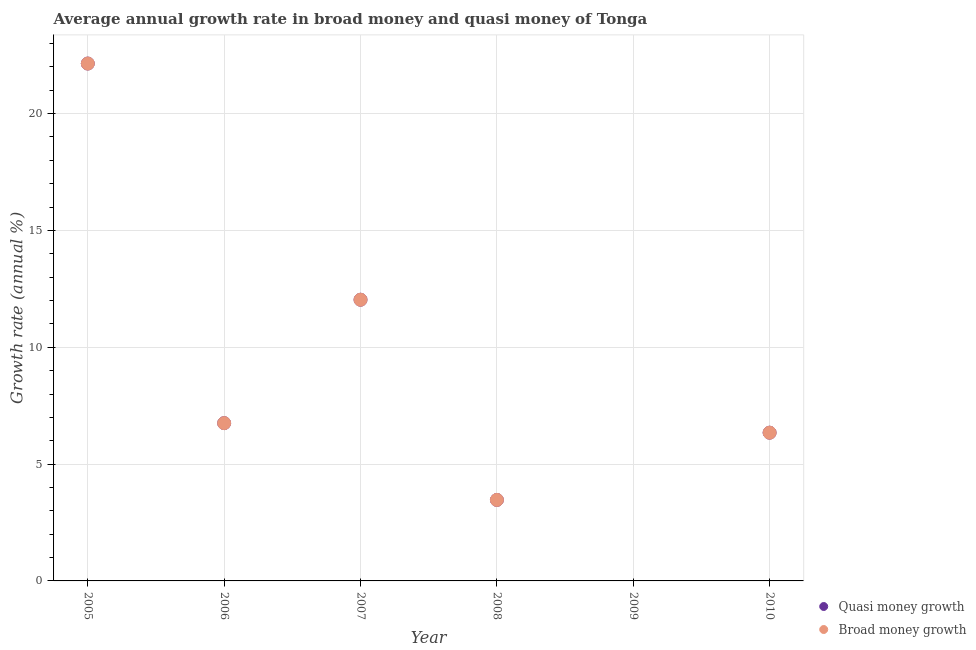Across all years, what is the maximum annual growth rate in broad money?
Keep it short and to the point. 22.14. In which year was the annual growth rate in broad money maximum?
Offer a terse response. 2005. What is the total annual growth rate in broad money in the graph?
Your answer should be compact. 50.74. What is the difference between the annual growth rate in quasi money in 2006 and that in 2010?
Provide a succinct answer. 0.41. What is the difference between the annual growth rate in quasi money in 2010 and the annual growth rate in broad money in 2009?
Provide a short and direct response. 6.34. What is the average annual growth rate in quasi money per year?
Your response must be concise. 8.46. In the year 2007, what is the difference between the annual growth rate in quasi money and annual growth rate in broad money?
Offer a very short reply. 0. In how many years, is the annual growth rate in quasi money greater than 10 %?
Keep it short and to the point. 2. What is the ratio of the annual growth rate in quasi money in 2005 to that in 2007?
Your answer should be very brief. 1.84. Is the difference between the annual growth rate in broad money in 2005 and 2007 greater than the difference between the annual growth rate in quasi money in 2005 and 2007?
Your answer should be very brief. No. What is the difference between the highest and the second highest annual growth rate in broad money?
Keep it short and to the point. 10.11. What is the difference between the highest and the lowest annual growth rate in quasi money?
Your response must be concise. 22.14. In how many years, is the annual growth rate in quasi money greater than the average annual growth rate in quasi money taken over all years?
Provide a succinct answer. 2. Does the annual growth rate in quasi money monotonically increase over the years?
Offer a terse response. No. Does the graph contain any zero values?
Your response must be concise. Yes. Does the graph contain grids?
Your response must be concise. Yes. Where does the legend appear in the graph?
Offer a terse response. Bottom right. How many legend labels are there?
Your answer should be very brief. 2. How are the legend labels stacked?
Offer a terse response. Vertical. What is the title of the graph?
Ensure brevity in your answer.  Average annual growth rate in broad money and quasi money of Tonga. What is the label or title of the Y-axis?
Your answer should be compact. Growth rate (annual %). What is the Growth rate (annual %) of Quasi money growth in 2005?
Provide a short and direct response. 22.14. What is the Growth rate (annual %) in Broad money growth in 2005?
Offer a terse response. 22.14. What is the Growth rate (annual %) in Quasi money growth in 2006?
Your answer should be very brief. 6.75. What is the Growth rate (annual %) of Broad money growth in 2006?
Give a very brief answer. 6.75. What is the Growth rate (annual %) in Quasi money growth in 2007?
Your answer should be very brief. 12.03. What is the Growth rate (annual %) of Broad money growth in 2007?
Give a very brief answer. 12.03. What is the Growth rate (annual %) of Quasi money growth in 2008?
Offer a very short reply. 3.47. What is the Growth rate (annual %) of Broad money growth in 2008?
Give a very brief answer. 3.47. What is the Growth rate (annual %) in Quasi money growth in 2009?
Provide a succinct answer. 0. What is the Growth rate (annual %) in Broad money growth in 2009?
Ensure brevity in your answer.  0. What is the Growth rate (annual %) of Quasi money growth in 2010?
Your answer should be very brief. 6.34. What is the Growth rate (annual %) in Broad money growth in 2010?
Give a very brief answer. 6.34. Across all years, what is the maximum Growth rate (annual %) of Quasi money growth?
Give a very brief answer. 22.14. Across all years, what is the maximum Growth rate (annual %) in Broad money growth?
Offer a terse response. 22.14. Across all years, what is the minimum Growth rate (annual %) of Quasi money growth?
Provide a short and direct response. 0. Across all years, what is the minimum Growth rate (annual %) in Broad money growth?
Your answer should be compact. 0. What is the total Growth rate (annual %) in Quasi money growth in the graph?
Provide a succinct answer. 50.74. What is the total Growth rate (annual %) of Broad money growth in the graph?
Offer a terse response. 50.74. What is the difference between the Growth rate (annual %) of Quasi money growth in 2005 and that in 2006?
Your answer should be very brief. 15.39. What is the difference between the Growth rate (annual %) of Broad money growth in 2005 and that in 2006?
Provide a short and direct response. 15.39. What is the difference between the Growth rate (annual %) in Quasi money growth in 2005 and that in 2007?
Your answer should be very brief. 10.11. What is the difference between the Growth rate (annual %) of Broad money growth in 2005 and that in 2007?
Keep it short and to the point. 10.11. What is the difference between the Growth rate (annual %) in Quasi money growth in 2005 and that in 2008?
Provide a short and direct response. 18.68. What is the difference between the Growth rate (annual %) in Broad money growth in 2005 and that in 2008?
Your answer should be compact. 18.68. What is the difference between the Growth rate (annual %) in Quasi money growth in 2005 and that in 2010?
Keep it short and to the point. 15.8. What is the difference between the Growth rate (annual %) in Broad money growth in 2005 and that in 2010?
Offer a terse response. 15.8. What is the difference between the Growth rate (annual %) in Quasi money growth in 2006 and that in 2007?
Your answer should be very brief. -5.28. What is the difference between the Growth rate (annual %) in Broad money growth in 2006 and that in 2007?
Provide a succinct answer. -5.28. What is the difference between the Growth rate (annual %) in Quasi money growth in 2006 and that in 2008?
Your answer should be very brief. 3.29. What is the difference between the Growth rate (annual %) of Broad money growth in 2006 and that in 2008?
Ensure brevity in your answer.  3.29. What is the difference between the Growth rate (annual %) in Quasi money growth in 2006 and that in 2010?
Give a very brief answer. 0.41. What is the difference between the Growth rate (annual %) of Broad money growth in 2006 and that in 2010?
Give a very brief answer. 0.41. What is the difference between the Growth rate (annual %) of Quasi money growth in 2007 and that in 2008?
Provide a succinct answer. 8.57. What is the difference between the Growth rate (annual %) of Broad money growth in 2007 and that in 2008?
Provide a succinct answer. 8.57. What is the difference between the Growth rate (annual %) of Quasi money growth in 2007 and that in 2010?
Your answer should be very brief. 5.69. What is the difference between the Growth rate (annual %) of Broad money growth in 2007 and that in 2010?
Keep it short and to the point. 5.69. What is the difference between the Growth rate (annual %) in Quasi money growth in 2008 and that in 2010?
Give a very brief answer. -2.88. What is the difference between the Growth rate (annual %) in Broad money growth in 2008 and that in 2010?
Ensure brevity in your answer.  -2.88. What is the difference between the Growth rate (annual %) in Quasi money growth in 2005 and the Growth rate (annual %) in Broad money growth in 2006?
Provide a short and direct response. 15.39. What is the difference between the Growth rate (annual %) in Quasi money growth in 2005 and the Growth rate (annual %) in Broad money growth in 2007?
Your response must be concise. 10.11. What is the difference between the Growth rate (annual %) in Quasi money growth in 2005 and the Growth rate (annual %) in Broad money growth in 2008?
Ensure brevity in your answer.  18.68. What is the difference between the Growth rate (annual %) in Quasi money growth in 2005 and the Growth rate (annual %) in Broad money growth in 2010?
Your answer should be compact. 15.8. What is the difference between the Growth rate (annual %) of Quasi money growth in 2006 and the Growth rate (annual %) of Broad money growth in 2007?
Provide a succinct answer. -5.28. What is the difference between the Growth rate (annual %) in Quasi money growth in 2006 and the Growth rate (annual %) in Broad money growth in 2008?
Give a very brief answer. 3.29. What is the difference between the Growth rate (annual %) in Quasi money growth in 2006 and the Growth rate (annual %) in Broad money growth in 2010?
Make the answer very short. 0.41. What is the difference between the Growth rate (annual %) of Quasi money growth in 2007 and the Growth rate (annual %) of Broad money growth in 2008?
Your answer should be very brief. 8.57. What is the difference between the Growth rate (annual %) in Quasi money growth in 2007 and the Growth rate (annual %) in Broad money growth in 2010?
Give a very brief answer. 5.69. What is the difference between the Growth rate (annual %) in Quasi money growth in 2008 and the Growth rate (annual %) in Broad money growth in 2010?
Give a very brief answer. -2.88. What is the average Growth rate (annual %) of Quasi money growth per year?
Keep it short and to the point. 8.46. What is the average Growth rate (annual %) of Broad money growth per year?
Your response must be concise. 8.46. In the year 2007, what is the difference between the Growth rate (annual %) in Quasi money growth and Growth rate (annual %) in Broad money growth?
Offer a very short reply. 0. In the year 2008, what is the difference between the Growth rate (annual %) in Quasi money growth and Growth rate (annual %) in Broad money growth?
Keep it short and to the point. 0. In the year 2010, what is the difference between the Growth rate (annual %) of Quasi money growth and Growth rate (annual %) of Broad money growth?
Give a very brief answer. 0. What is the ratio of the Growth rate (annual %) in Quasi money growth in 2005 to that in 2006?
Ensure brevity in your answer.  3.28. What is the ratio of the Growth rate (annual %) in Broad money growth in 2005 to that in 2006?
Your answer should be compact. 3.28. What is the ratio of the Growth rate (annual %) of Quasi money growth in 2005 to that in 2007?
Your response must be concise. 1.84. What is the ratio of the Growth rate (annual %) of Broad money growth in 2005 to that in 2007?
Your answer should be very brief. 1.84. What is the ratio of the Growth rate (annual %) of Quasi money growth in 2005 to that in 2008?
Your answer should be very brief. 6.39. What is the ratio of the Growth rate (annual %) in Broad money growth in 2005 to that in 2008?
Give a very brief answer. 6.39. What is the ratio of the Growth rate (annual %) in Quasi money growth in 2005 to that in 2010?
Keep it short and to the point. 3.49. What is the ratio of the Growth rate (annual %) of Broad money growth in 2005 to that in 2010?
Offer a very short reply. 3.49. What is the ratio of the Growth rate (annual %) of Quasi money growth in 2006 to that in 2007?
Keep it short and to the point. 0.56. What is the ratio of the Growth rate (annual %) in Broad money growth in 2006 to that in 2007?
Your answer should be compact. 0.56. What is the ratio of the Growth rate (annual %) of Quasi money growth in 2006 to that in 2008?
Give a very brief answer. 1.95. What is the ratio of the Growth rate (annual %) of Broad money growth in 2006 to that in 2008?
Make the answer very short. 1.95. What is the ratio of the Growth rate (annual %) of Quasi money growth in 2006 to that in 2010?
Your answer should be compact. 1.06. What is the ratio of the Growth rate (annual %) in Broad money growth in 2006 to that in 2010?
Keep it short and to the point. 1.06. What is the ratio of the Growth rate (annual %) of Quasi money growth in 2007 to that in 2008?
Provide a short and direct response. 3.47. What is the ratio of the Growth rate (annual %) of Broad money growth in 2007 to that in 2008?
Give a very brief answer. 3.47. What is the ratio of the Growth rate (annual %) of Quasi money growth in 2007 to that in 2010?
Provide a short and direct response. 1.9. What is the ratio of the Growth rate (annual %) of Broad money growth in 2007 to that in 2010?
Keep it short and to the point. 1.9. What is the ratio of the Growth rate (annual %) of Quasi money growth in 2008 to that in 2010?
Offer a very short reply. 0.55. What is the ratio of the Growth rate (annual %) in Broad money growth in 2008 to that in 2010?
Provide a succinct answer. 0.55. What is the difference between the highest and the second highest Growth rate (annual %) in Quasi money growth?
Offer a very short reply. 10.11. What is the difference between the highest and the second highest Growth rate (annual %) in Broad money growth?
Your answer should be very brief. 10.11. What is the difference between the highest and the lowest Growth rate (annual %) in Quasi money growth?
Offer a very short reply. 22.14. What is the difference between the highest and the lowest Growth rate (annual %) of Broad money growth?
Provide a short and direct response. 22.14. 